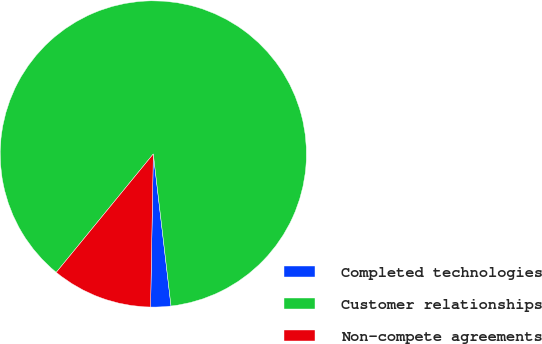Convert chart to OTSL. <chart><loc_0><loc_0><loc_500><loc_500><pie_chart><fcel>Completed technologies<fcel>Customer relationships<fcel>Non-compete agreements<nl><fcel>2.13%<fcel>87.23%<fcel>10.64%<nl></chart> 